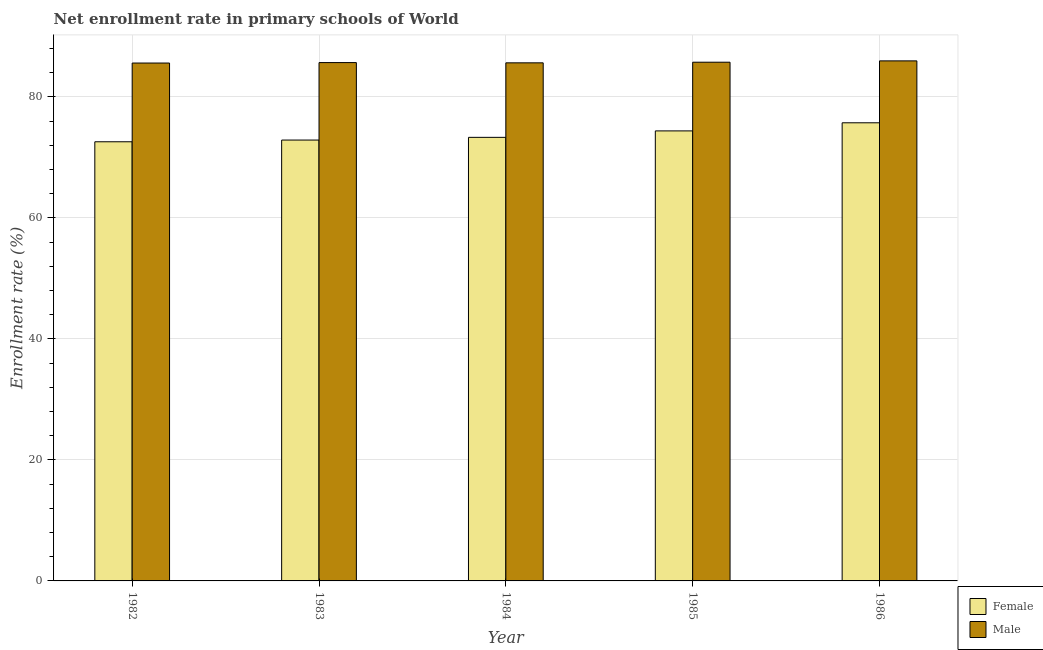How many groups of bars are there?
Your answer should be very brief. 5. Are the number of bars per tick equal to the number of legend labels?
Keep it short and to the point. Yes. How many bars are there on the 5th tick from the left?
Ensure brevity in your answer.  2. How many bars are there on the 3rd tick from the right?
Your answer should be very brief. 2. What is the enrollment rate of male students in 1984?
Your answer should be compact. 85.64. Across all years, what is the maximum enrollment rate of male students?
Ensure brevity in your answer.  85.96. Across all years, what is the minimum enrollment rate of female students?
Keep it short and to the point. 72.59. What is the total enrollment rate of male students in the graph?
Your answer should be very brief. 428.62. What is the difference between the enrollment rate of male students in 1982 and that in 1985?
Your answer should be very brief. -0.14. What is the difference between the enrollment rate of male students in 1986 and the enrollment rate of female students in 1985?
Ensure brevity in your answer.  0.22. What is the average enrollment rate of male students per year?
Provide a short and direct response. 85.72. In how many years, is the enrollment rate of female students greater than 80 %?
Provide a succinct answer. 0. What is the ratio of the enrollment rate of female students in 1982 to that in 1983?
Offer a terse response. 1. Is the enrollment rate of male students in 1982 less than that in 1983?
Your response must be concise. Yes. What is the difference between the highest and the second highest enrollment rate of male students?
Your answer should be compact. 0.22. What is the difference between the highest and the lowest enrollment rate of female students?
Offer a terse response. 3.14. In how many years, is the enrollment rate of female students greater than the average enrollment rate of female students taken over all years?
Ensure brevity in your answer.  2. What does the 2nd bar from the left in 1984 represents?
Give a very brief answer. Male. What does the 2nd bar from the right in 1986 represents?
Offer a terse response. Female. Are all the bars in the graph horizontal?
Offer a terse response. No. How many years are there in the graph?
Your response must be concise. 5. Are the values on the major ticks of Y-axis written in scientific E-notation?
Provide a short and direct response. No. Does the graph contain grids?
Your answer should be compact. Yes. How many legend labels are there?
Ensure brevity in your answer.  2. How are the legend labels stacked?
Your answer should be compact. Vertical. What is the title of the graph?
Your answer should be compact. Net enrollment rate in primary schools of World. Does "Manufacturing industries and construction" appear as one of the legend labels in the graph?
Keep it short and to the point. No. What is the label or title of the X-axis?
Give a very brief answer. Year. What is the label or title of the Y-axis?
Give a very brief answer. Enrollment rate (%). What is the Enrollment rate (%) of Female in 1982?
Offer a very short reply. 72.59. What is the Enrollment rate (%) of Male in 1982?
Your answer should be compact. 85.6. What is the Enrollment rate (%) of Female in 1983?
Ensure brevity in your answer.  72.87. What is the Enrollment rate (%) of Male in 1983?
Give a very brief answer. 85.68. What is the Enrollment rate (%) in Female in 1984?
Offer a very short reply. 73.32. What is the Enrollment rate (%) of Male in 1984?
Make the answer very short. 85.64. What is the Enrollment rate (%) in Female in 1985?
Provide a succinct answer. 74.39. What is the Enrollment rate (%) of Male in 1985?
Offer a very short reply. 85.74. What is the Enrollment rate (%) in Female in 1986?
Give a very brief answer. 75.73. What is the Enrollment rate (%) in Male in 1986?
Keep it short and to the point. 85.96. Across all years, what is the maximum Enrollment rate (%) in Female?
Your answer should be compact. 75.73. Across all years, what is the maximum Enrollment rate (%) of Male?
Provide a short and direct response. 85.96. Across all years, what is the minimum Enrollment rate (%) of Female?
Give a very brief answer. 72.59. Across all years, what is the minimum Enrollment rate (%) in Male?
Keep it short and to the point. 85.6. What is the total Enrollment rate (%) of Female in the graph?
Provide a short and direct response. 368.9. What is the total Enrollment rate (%) of Male in the graph?
Your answer should be very brief. 428.62. What is the difference between the Enrollment rate (%) in Female in 1982 and that in 1983?
Give a very brief answer. -0.28. What is the difference between the Enrollment rate (%) of Male in 1982 and that in 1983?
Your answer should be very brief. -0.07. What is the difference between the Enrollment rate (%) in Female in 1982 and that in 1984?
Your answer should be very brief. -0.73. What is the difference between the Enrollment rate (%) of Male in 1982 and that in 1984?
Your answer should be compact. -0.03. What is the difference between the Enrollment rate (%) in Female in 1982 and that in 1985?
Ensure brevity in your answer.  -1.8. What is the difference between the Enrollment rate (%) in Male in 1982 and that in 1985?
Provide a succinct answer. -0.14. What is the difference between the Enrollment rate (%) in Female in 1982 and that in 1986?
Provide a succinct answer. -3.14. What is the difference between the Enrollment rate (%) in Male in 1982 and that in 1986?
Give a very brief answer. -0.36. What is the difference between the Enrollment rate (%) of Female in 1983 and that in 1984?
Offer a terse response. -0.45. What is the difference between the Enrollment rate (%) in Male in 1983 and that in 1984?
Provide a short and direct response. 0.04. What is the difference between the Enrollment rate (%) in Female in 1983 and that in 1985?
Offer a very short reply. -1.51. What is the difference between the Enrollment rate (%) of Male in 1983 and that in 1985?
Your response must be concise. -0.06. What is the difference between the Enrollment rate (%) of Female in 1983 and that in 1986?
Keep it short and to the point. -2.85. What is the difference between the Enrollment rate (%) of Male in 1983 and that in 1986?
Give a very brief answer. -0.28. What is the difference between the Enrollment rate (%) of Female in 1984 and that in 1985?
Provide a succinct answer. -1.07. What is the difference between the Enrollment rate (%) in Male in 1984 and that in 1985?
Offer a terse response. -0.11. What is the difference between the Enrollment rate (%) of Female in 1984 and that in 1986?
Your response must be concise. -2.41. What is the difference between the Enrollment rate (%) in Male in 1984 and that in 1986?
Your answer should be compact. -0.32. What is the difference between the Enrollment rate (%) of Female in 1985 and that in 1986?
Offer a terse response. -1.34. What is the difference between the Enrollment rate (%) of Male in 1985 and that in 1986?
Your response must be concise. -0.22. What is the difference between the Enrollment rate (%) of Female in 1982 and the Enrollment rate (%) of Male in 1983?
Offer a very short reply. -13.09. What is the difference between the Enrollment rate (%) in Female in 1982 and the Enrollment rate (%) in Male in 1984?
Keep it short and to the point. -13.05. What is the difference between the Enrollment rate (%) in Female in 1982 and the Enrollment rate (%) in Male in 1985?
Provide a short and direct response. -13.15. What is the difference between the Enrollment rate (%) of Female in 1982 and the Enrollment rate (%) of Male in 1986?
Your answer should be very brief. -13.37. What is the difference between the Enrollment rate (%) in Female in 1983 and the Enrollment rate (%) in Male in 1984?
Your response must be concise. -12.76. What is the difference between the Enrollment rate (%) of Female in 1983 and the Enrollment rate (%) of Male in 1985?
Offer a terse response. -12.87. What is the difference between the Enrollment rate (%) of Female in 1983 and the Enrollment rate (%) of Male in 1986?
Give a very brief answer. -13.09. What is the difference between the Enrollment rate (%) in Female in 1984 and the Enrollment rate (%) in Male in 1985?
Your answer should be very brief. -12.42. What is the difference between the Enrollment rate (%) in Female in 1984 and the Enrollment rate (%) in Male in 1986?
Your response must be concise. -12.64. What is the difference between the Enrollment rate (%) of Female in 1985 and the Enrollment rate (%) of Male in 1986?
Make the answer very short. -11.57. What is the average Enrollment rate (%) in Female per year?
Your answer should be compact. 73.78. What is the average Enrollment rate (%) in Male per year?
Provide a succinct answer. 85.72. In the year 1982, what is the difference between the Enrollment rate (%) of Female and Enrollment rate (%) of Male?
Provide a succinct answer. -13.01. In the year 1983, what is the difference between the Enrollment rate (%) in Female and Enrollment rate (%) in Male?
Your answer should be compact. -12.81. In the year 1984, what is the difference between the Enrollment rate (%) in Female and Enrollment rate (%) in Male?
Give a very brief answer. -12.32. In the year 1985, what is the difference between the Enrollment rate (%) of Female and Enrollment rate (%) of Male?
Provide a succinct answer. -11.36. In the year 1986, what is the difference between the Enrollment rate (%) in Female and Enrollment rate (%) in Male?
Provide a succinct answer. -10.23. What is the ratio of the Enrollment rate (%) of Female in 1982 to that in 1985?
Ensure brevity in your answer.  0.98. What is the ratio of the Enrollment rate (%) of Female in 1982 to that in 1986?
Offer a very short reply. 0.96. What is the ratio of the Enrollment rate (%) of Female in 1983 to that in 1984?
Your answer should be compact. 0.99. What is the ratio of the Enrollment rate (%) in Male in 1983 to that in 1984?
Ensure brevity in your answer.  1. What is the ratio of the Enrollment rate (%) of Female in 1983 to that in 1985?
Provide a succinct answer. 0.98. What is the ratio of the Enrollment rate (%) in Female in 1983 to that in 1986?
Keep it short and to the point. 0.96. What is the ratio of the Enrollment rate (%) of Female in 1984 to that in 1985?
Your answer should be very brief. 0.99. What is the ratio of the Enrollment rate (%) of Male in 1984 to that in 1985?
Give a very brief answer. 1. What is the ratio of the Enrollment rate (%) in Female in 1984 to that in 1986?
Offer a very short reply. 0.97. What is the ratio of the Enrollment rate (%) in Female in 1985 to that in 1986?
Ensure brevity in your answer.  0.98. What is the difference between the highest and the second highest Enrollment rate (%) of Female?
Your answer should be very brief. 1.34. What is the difference between the highest and the second highest Enrollment rate (%) of Male?
Offer a very short reply. 0.22. What is the difference between the highest and the lowest Enrollment rate (%) in Female?
Provide a short and direct response. 3.14. What is the difference between the highest and the lowest Enrollment rate (%) of Male?
Your answer should be compact. 0.36. 